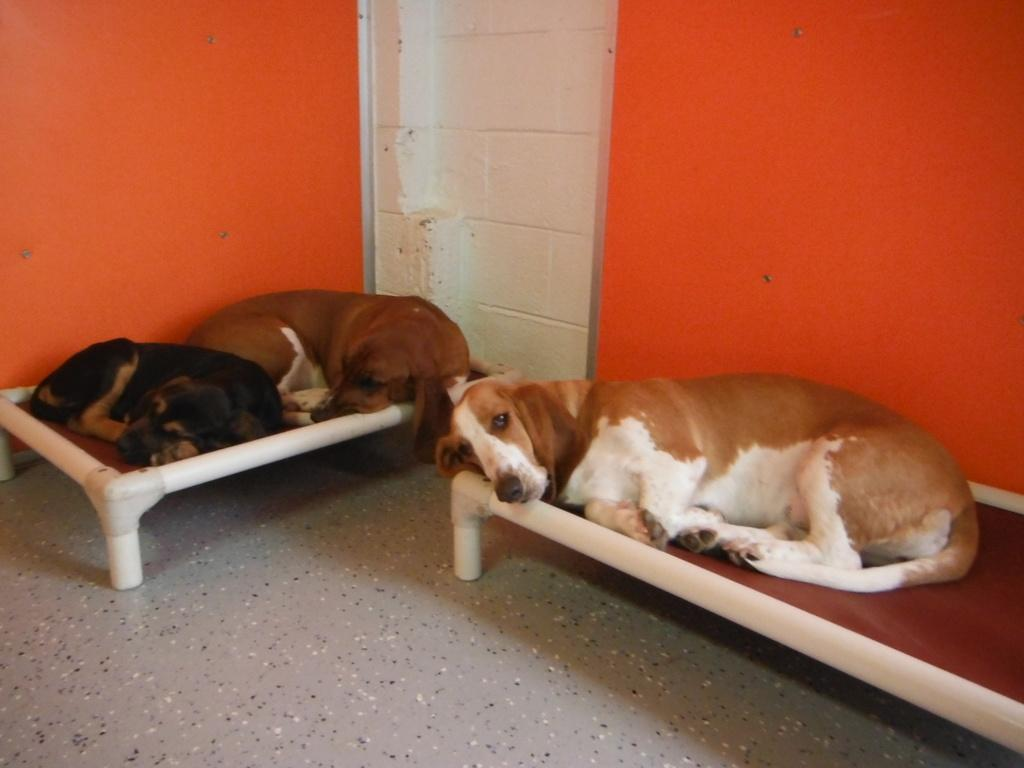How many dogs are present in the image? There are three dogs in the image. What are the dogs doing in the image? The dogs are sleeping. On what object are the dogs resting? The dogs are on an object. What colors can be seen on the background wall in the image? The background wall is in orange and white color. Can you tell me how many grapes are on the orange and white wall in the image? There are no grapes present on the orange and white wall in the image. What type of knot is being used to secure the dogs to the object in the image? There is no knot visible in the image, as the dogs are not tied to the object. 